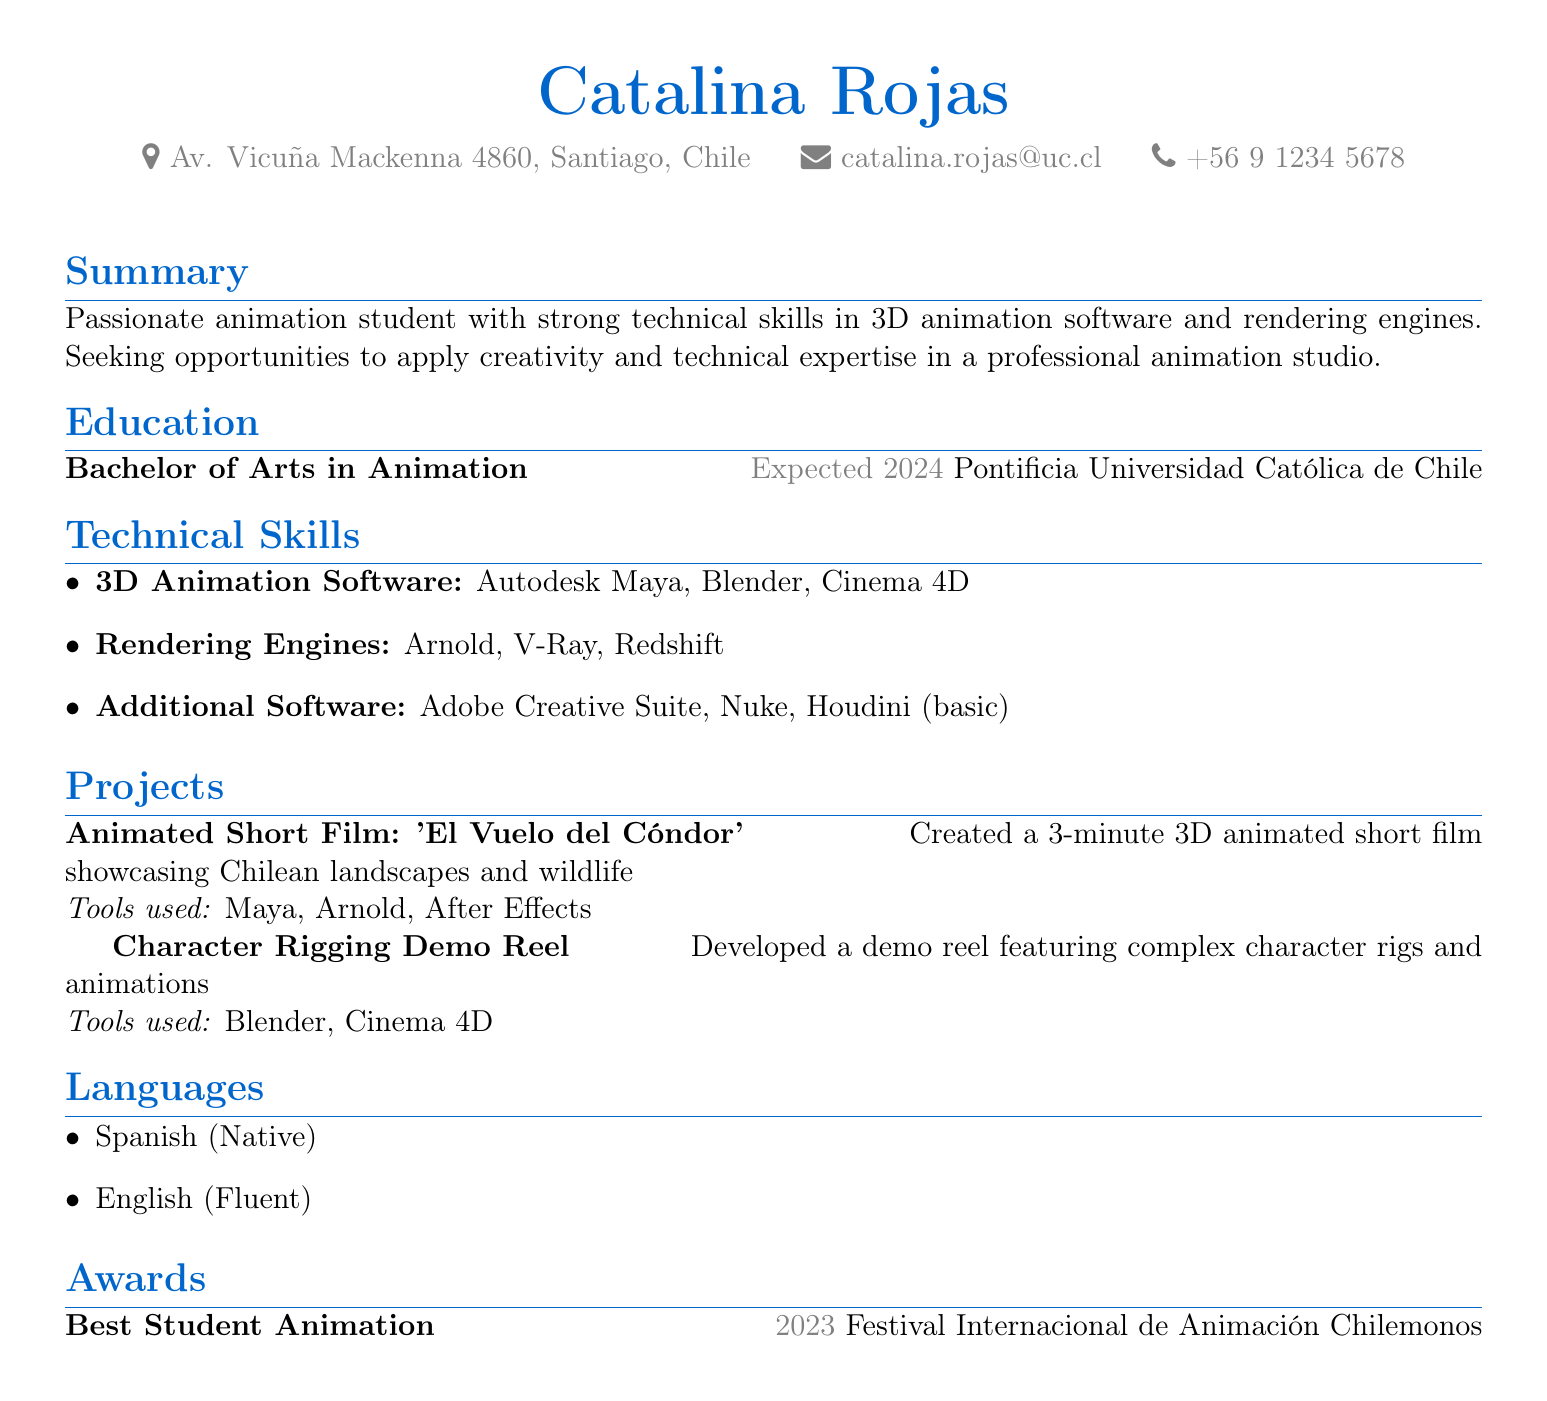what is Catalina Rojas's degree? The degree listed in the document is a Bachelor of Arts in Animation.
Answer: Bachelor of Arts in Animation what is the expected graduation year? The expected graduation year mentioned in the document is 2024.
Answer: 2024 which university is she attending? The institution where she is studying is Pontificia Universidad Católica de Chile.
Answer: Pontificia Universidad Católica de Chile name one 3D animation software she is proficient in. The document lists several, one of which is Autodesk Maya.
Answer: Autodesk Maya what award did Catalina Rojas win in 2023? The document states that she won the Best Student Animation award.
Answer: Best Student Animation which rendering engine is mentioned first in her technical skills? The first rendering engine listed in the document is Arnold.
Answer: Arnold how many languages does she speak? The document indicates she speaks two languages.
Answer: Two what is the title of her animated short film? The title of the animated short film is 'El Vuelo del Cóndor'.
Answer: 'El Vuelo del Cóndor' which software was used for the Character Rigging Demo Reel? The document mentions that Blender and Cinema 4D were used.
Answer: Blender, Cinema 4D 